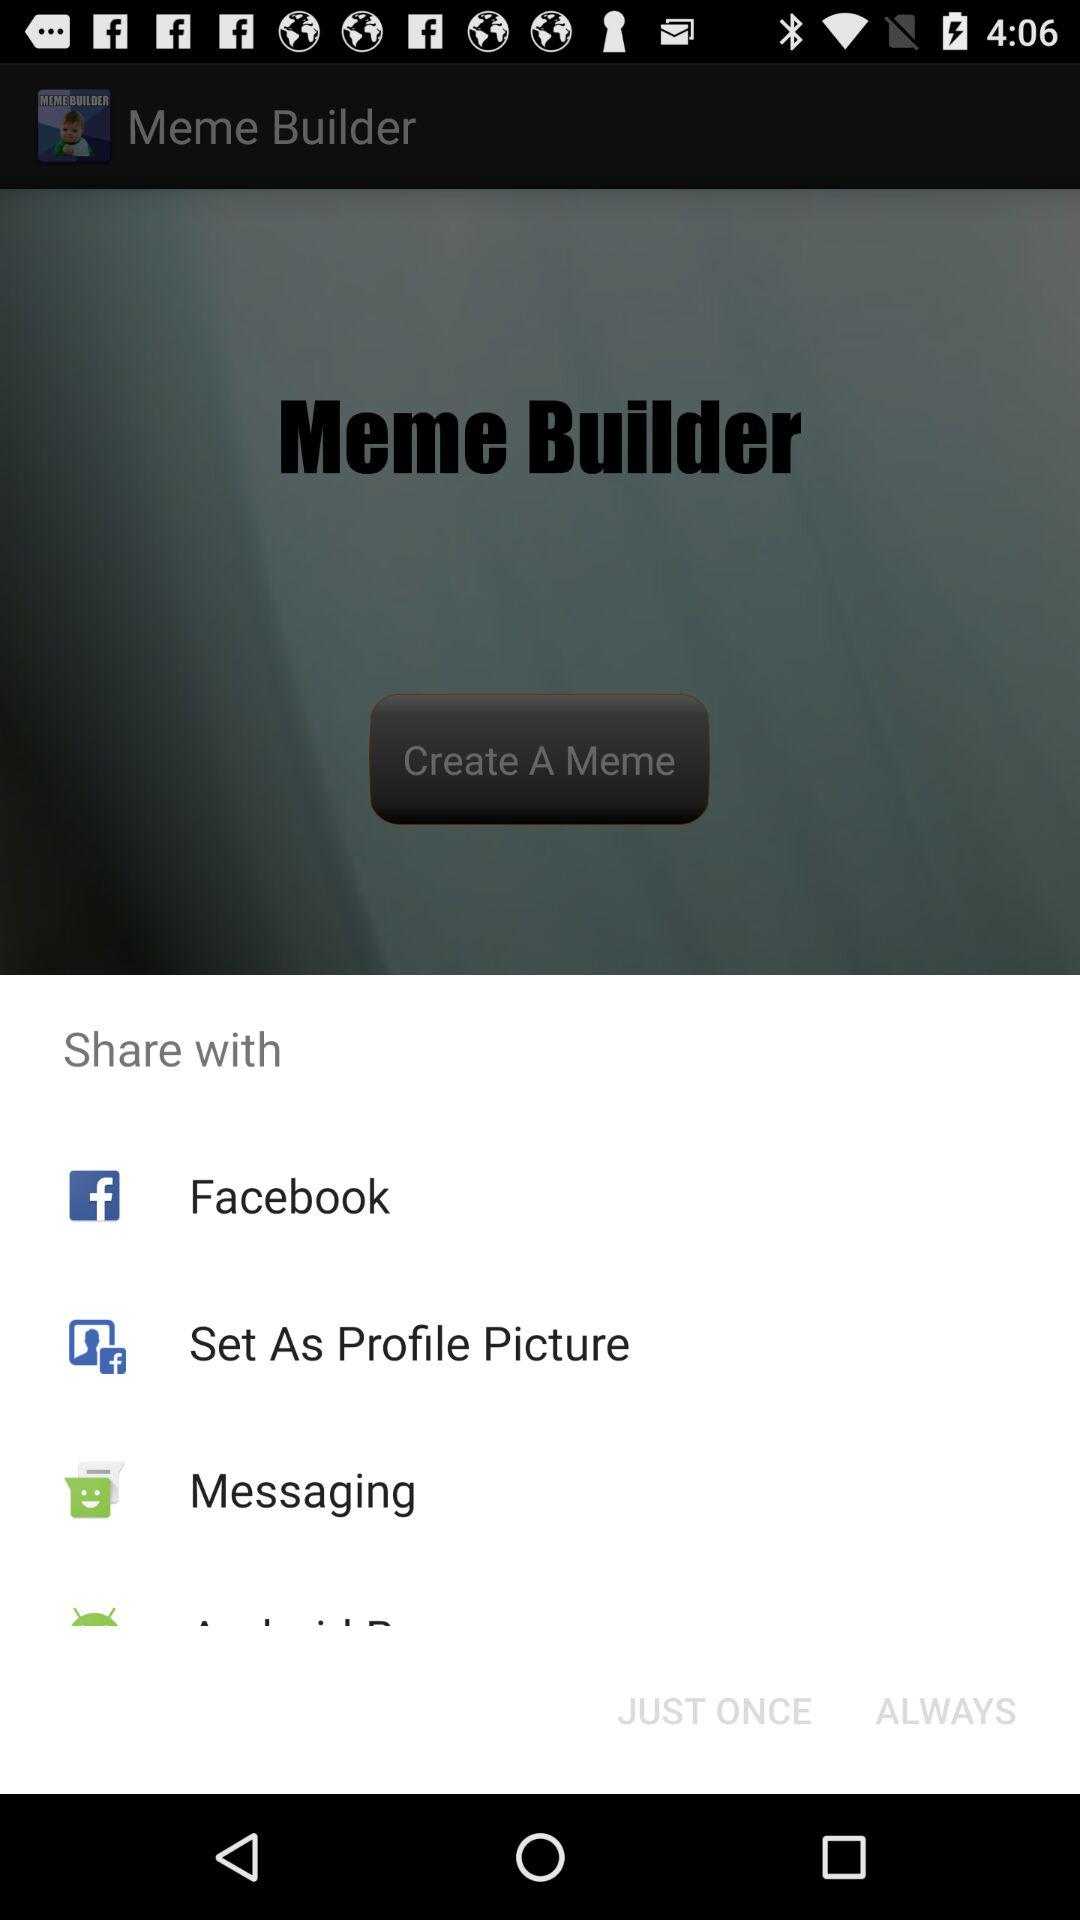How many share options are there?
Answer the question using a single word or phrase. 4 